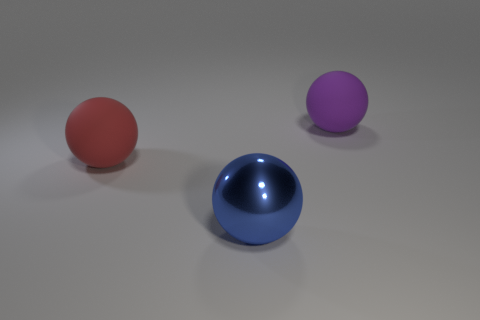How many things are there?
Give a very brief answer. 3. Are there any green metallic cylinders of the same size as the blue sphere?
Your response must be concise. No. Is the number of purple things that are in front of the large red matte object less than the number of yellow balls?
Offer a very short reply. No. Do the red rubber object and the purple rubber sphere have the same size?
Offer a very short reply. Yes. There is a red object that is the same material as the purple thing; what is its size?
Your answer should be compact. Large. What number of matte things are the same color as the shiny object?
Your response must be concise. 0. Is the number of large purple objects on the left side of the purple rubber thing less than the number of blue things that are behind the large blue thing?
Keep it short and to the point. No. There is a big rubber object left of the big shiny sphere; does it have the same shape as the metallic object?
Keep it short and to the point. Yes. Is there any other thing that is made of the same material as the large purple ball?
Provide a succinct answer. Yes. Do the large object that is right of the metallic thing and the blue object have the same material?
Offer a terse response. No. 